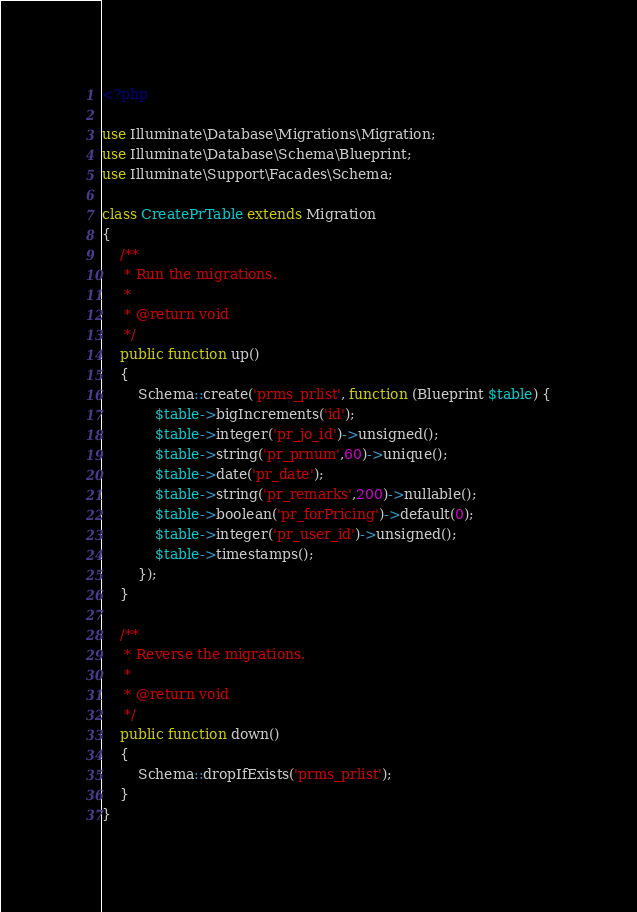<code> <loc_0><loc_0><loc_500><loc_500><_PHP_><?php

use Illuminate\Database\Migrations\Migration;
use Illuminate\Database\Schema\Blueprint;
use Illuminate\Support\Facades\Schema;

class CreatePrTable extends Migration
{
    /**
     * Run the migrations.
     *
     * @return void
     */
    public function up()
    {
        Schema::create('prms_prlist', function (Blueprint $table) {
            $table->bigIncrements('id');
            $table->integer('pr_jo_id')->unsigned();
            $table->string('pr_prnum',60)->unique();
            $table->date('pr_date');
            $table->string('pr_remarks',200)->nullable();
            $table->boolean('pr_forPricing')->default(0);
            $table->integer('pr_user_id')->unsigned();
            $table->timestamps();
        });
    }

    /**
     * Reverse the migrations.
     *
     * @return void
     */
    public function down()
    {
        Schema::dropIfExists('prms_prlist');
    }
}
</code> 